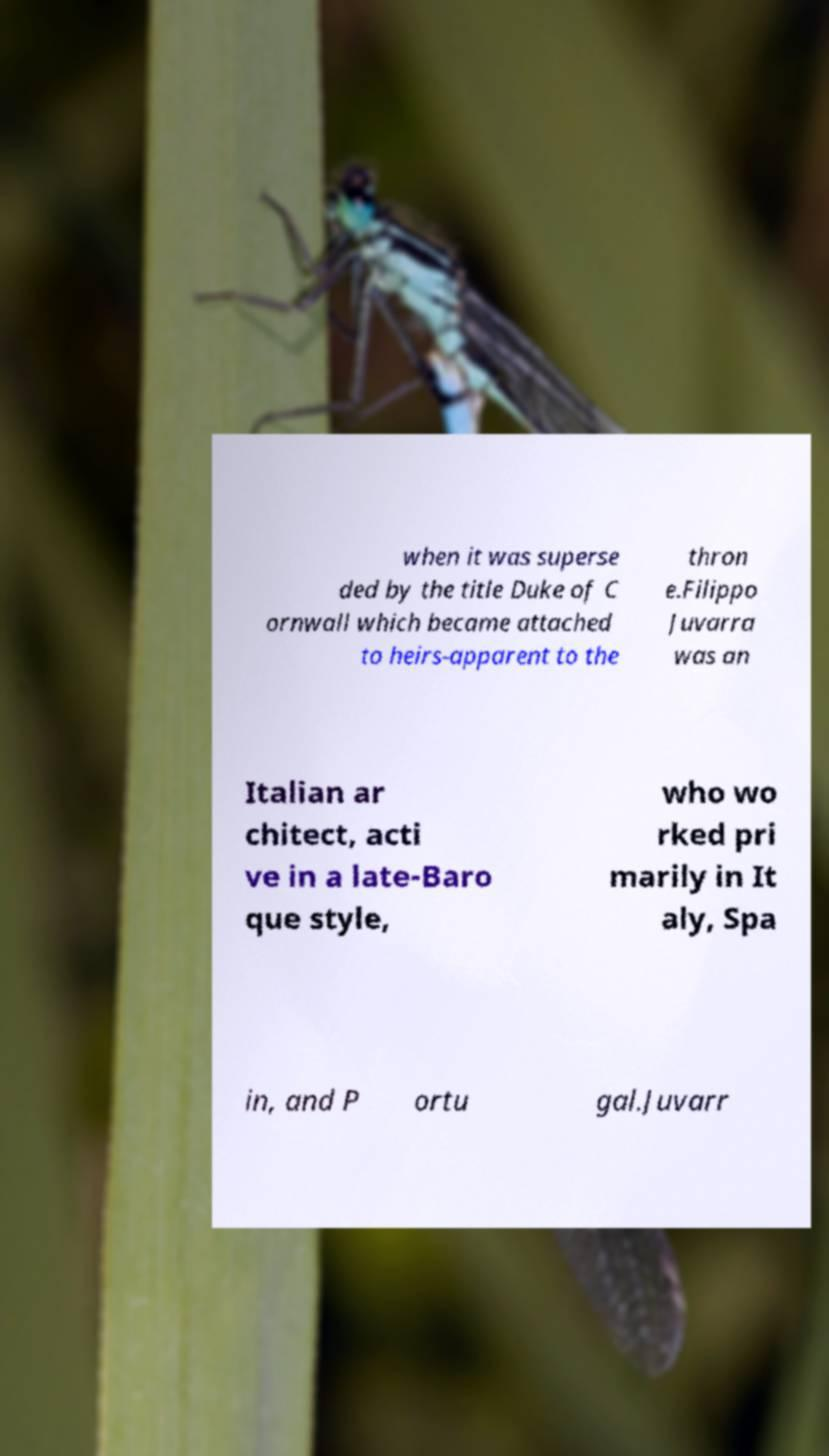Could you extract and type out the text from this image? when it was superse ded by the title Duke of C ornwall which became attached to heirs-apparent to the thron e.Filippo Juvarra was an Italian ar chitect, acti ve in a late-Baro que style, who wo rked pri marily in It aly, Spa in, and P ortu gal.Juvarr 